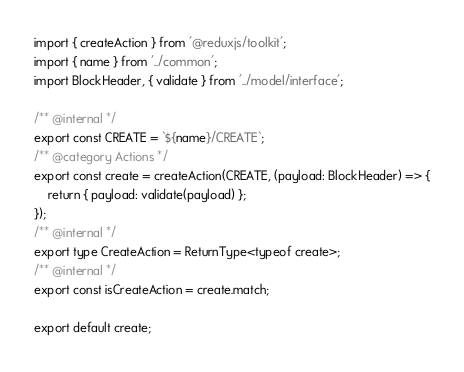<code> <loc_0><loc_0><loc_500><loc_500><_TypeScript_>import { createAction } from '@reduxjs/toolkit';
import { name } from '../common';
import BlockHeader, { validate } from '../model/interface';

/** @internal */
export const CREATE = `${name}/CREATE`;
/** @category Actions */
export const create = createAction(CREATE, (payload: BlockHeader) => {
    return { payload: validate(payload) };
});
/** @internal */
export type CreateAction = ReturnType<typeof create>;
/** @internal */
export const isCreateAction = create.match;

export default create;
</code> 